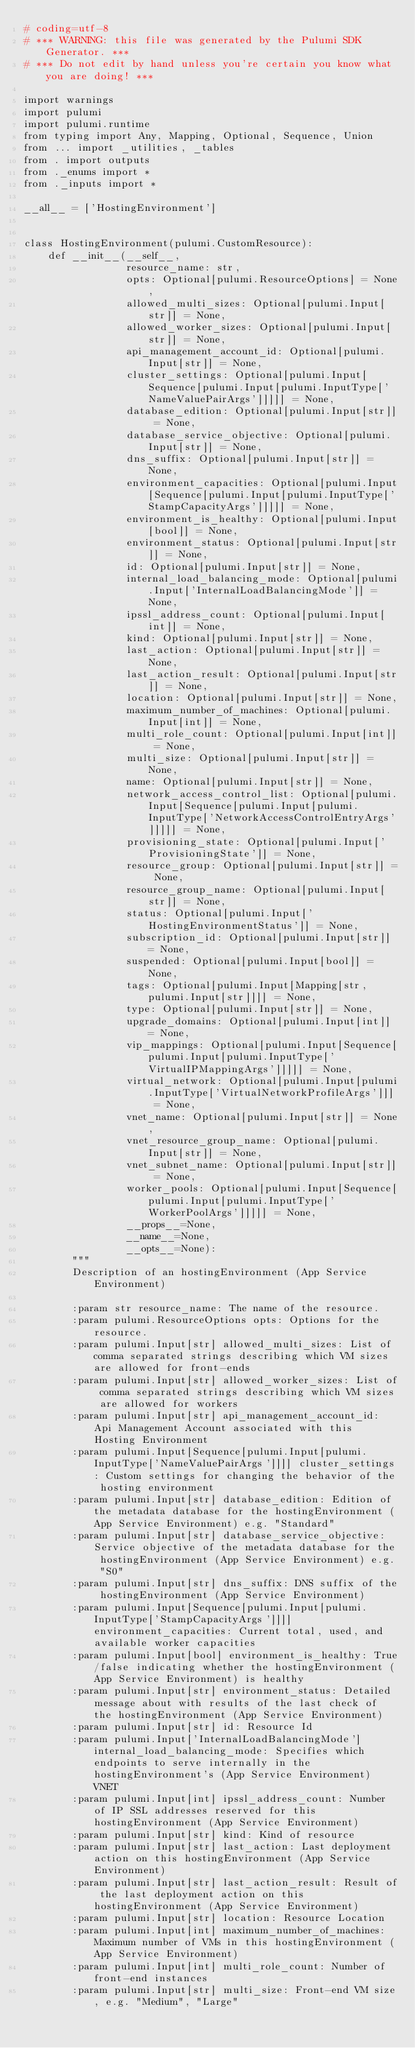<code> <loc_0><loc_0><loc_500><loc_500><_Python_># coding=utf-8
# *** WARNING: this file was generated by the Pulumi SDK Generator. ***
# *** Do not edit by hand unless you're certain you know what you are doing! ***

import warnings
import pulumi
import pulumi.runtime
from typing import Any, Mapping, Optional, Sequence, Union
from ... import _utilities, _tables
from . import outputs
from ._enums import *
from ._inputs import *

__all__ = ['HostingEnvironment']


class HostingEnvironment(pulumi.CustomResource):
    def __init__(__self__,
                 resource_name: str,
                 opts: Optional[pulumi.ResourceOptions] = None,
                 allowed_multi_sizes: Optional[pulumi.Input[str]] = None,
                 allowed_worker_sizes: Optional[pulumi.Input[str]] = None,
                 api_management_account_id: Optional[pulumi.Input[str]] = None,
                 cluster_settings: Optional[pulumi.Input[Sequence[pulumi.Input[pulumi.InputType['NameValuePairArgs']]]]] = None,
                 database_edition: Optional[pulumi.Input[str]] = None,
                 database_service_objective: Optional[pulumi.Input[str]] = None,
                 dns_suffix: Optional[pulumi.Input[str]] = None,
                 environment_capacities: Optional[pulumi.Input[Sequence[pulumi.Input[pulumi.InputType['StampCapacityArgs']]]]] = None,
                 environment_is_healthy: Optional[pulumi.Input[bool]] = None,
                 environment_status: Optional[pulumi.Input[str]] = None,
                 id: Optional[pulumi.Input[str]] = None,
                 internal_load_balancing_mode: Optional[pulumi.Input['InternalLoadBalancingMode']] = None,
                 ipssl_address_count: Optional[pulumi.Input[int]] = None,
                 kind: Optional[pulumi.Input[str]] = None,
                 last_action: Optional[pulumi.Input[str]] = None,
                 last_action_result: Optional[pulumi.Input[str]] = None,
                 location: Optional[pulumi.Input[str]] = None,
                 maximum_number_of_machines: Optional[pulumi.Input[int]] = None,
                 multi_role_count: Optional[pulumi.Input[int]] = None,
                 multi_size: Optional[pulumi.Input[str]] = None,
                 name: Optional[pulumi.Input[str]] = None,
                 network_access_control_list: Optional[pulumi.Input[Sequence[pulumi.Input[pulumi.InputType['NetworkAccessControlEntryArgs']]]]] = None,
                 provisioning_state: Optional[pulumi.Input['ProvisioningState']] = None,
                 resource_group: Optional[pulumi.Input[str]] = None,
                 resource_group_name: Optional[pulumi.Input[str]] = None,
                 status: Optional[pulumi.Input['HostingEnvironmentStatus']] = None,
                 subscription_id: Optional[pulumi.Input[str]] = None,
                 suspended: Optional[pulumi.Input[bool]] = None,
                 tags: Optional[pulumi.Input[Mapping[str, pulumi.Input[str]]]] = None,
                 type: Optional[pulumi.Input[str]] = None,
                 upgrade_domains: Optional[pulumi.Input[int]] = None,
                 vip_mappings: Optional[pulumi.Input[Sequence[pulumi.Input[pulumi.InputType['VirtualIPMappingArgs']]]]] = None,
                 virtual_network: Optional[pulumi.Input[pulumi.InputType['VirtualNetworkProfileArgs']]] = None,
                 vnet_name: Optional[pulumi.Input[str]] = None,
                 vnet_resource_group_name: Optional[pulumi.Input[str]] = None,
                 vnet_subnet_name: Optional[pulumi.Input[str]] = None,
                 worker_pools: Optional[pulumi.Input[Sequence[pulumi.Input[pulumi.InputType['WorkerPoolArgs']]]]] = None,
                 __props__=None,
                 __name__=None,
                 __opts__=None):
        """
        Description of an hostingEnvironment (App Service Environment)

        :param str resource_name: The name of the resource.
        :param pulumi.ResourceOptions opts: Options for the resource.
        :param pulumi.Input[str] allowed_multi_sizes: List of comma separated strings describing which VM sizes are allowed for front-ends
        :param pulumi.Input[str] allowed_worker_sizes: List of comma separated strings describing which VM sizes are allowed for workers
        :param pulumi.Input[str] api_management_account_id: Api Management Account associated with this Hosting Environment
        :param pulumi.Input[Sequence[pulumi.Input[pulumi.InputType['NameValuePairArgs']]]] cluster_settings: Custom settings for changing the behavior of the hosting environment
        :param pulumi.Input[str] database_edition: Edition of the metadata database for the hostingEnvironment (App Service Environment) e.g. "Standard"
        :param pulumi.Input[str] database_service_objective: Service objective of the metadata database for the hostingEnvironment (App Service Environment) e.g. "S0"
        :param pulumi.Input[str] dns_suffix: DNS suffix of the hostingEnvironment (App Service Environment)
        :param pulumi.Input[Sequence[pulumi.Input[pulumi.InputType['StampCapacityArgs']]]] environment_capacities: Current total, used, and available worker capacities
        :param pulumi.Input[bool] environment_is_healthy: True/false indicating whether the hostingEnvironment (App Service Environment) is healthy
        :param pulumi.Input[str] environment_status: Detailed message about with results of the last check of the hostingEnvironment (App Service Environment)
        :param pulumi.Input[str] id: Resource Id
        :param pulumi.Input['InternalLoadBalancingMode'] internal_load_balancing_mode: Specifies which endpoints to serve internally in the hostingEnvironment's (App Service Environment) VNET
        :param pulumi.Input[int] ipssl_address_count: Number of IP SSL addresses reserved for this hostingEnvironment (App Service Environment)
        :param pulumi.Input[str] kind: Kind of resource
        :param pulumi.Input[str] last_action: Last deployment action on this hostingEnvironment (App Service Environment)
        :param pulumi.Input[str] last_action_result: Result of the last deployment action on this hostingEnvironment (App Service Environment)
        :param pulumi.Input[str] location: Resource Location
        :param pulumi.Input[int] maximum_number_of_machines: Maximum number of VMs in this hostingEnvironment (App Service Environment)
        :param pulumi.Input[int] multi_role_count: Number of front-end instances
        :param pulumi.Input[str] multi_size: Front-end VM size, e.g. "Medium", "Large"</code> 